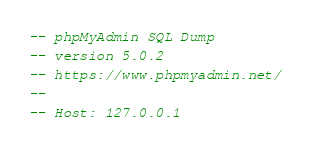<code> <loc_0><loc_0><loc_500><loc_500><_SQL_>-- phpMyAdmin SQL Dump
-- version 5.0.2
-- https://www.phpmyadmin.net/
--
-- Host: 127.0.0.1</code> 